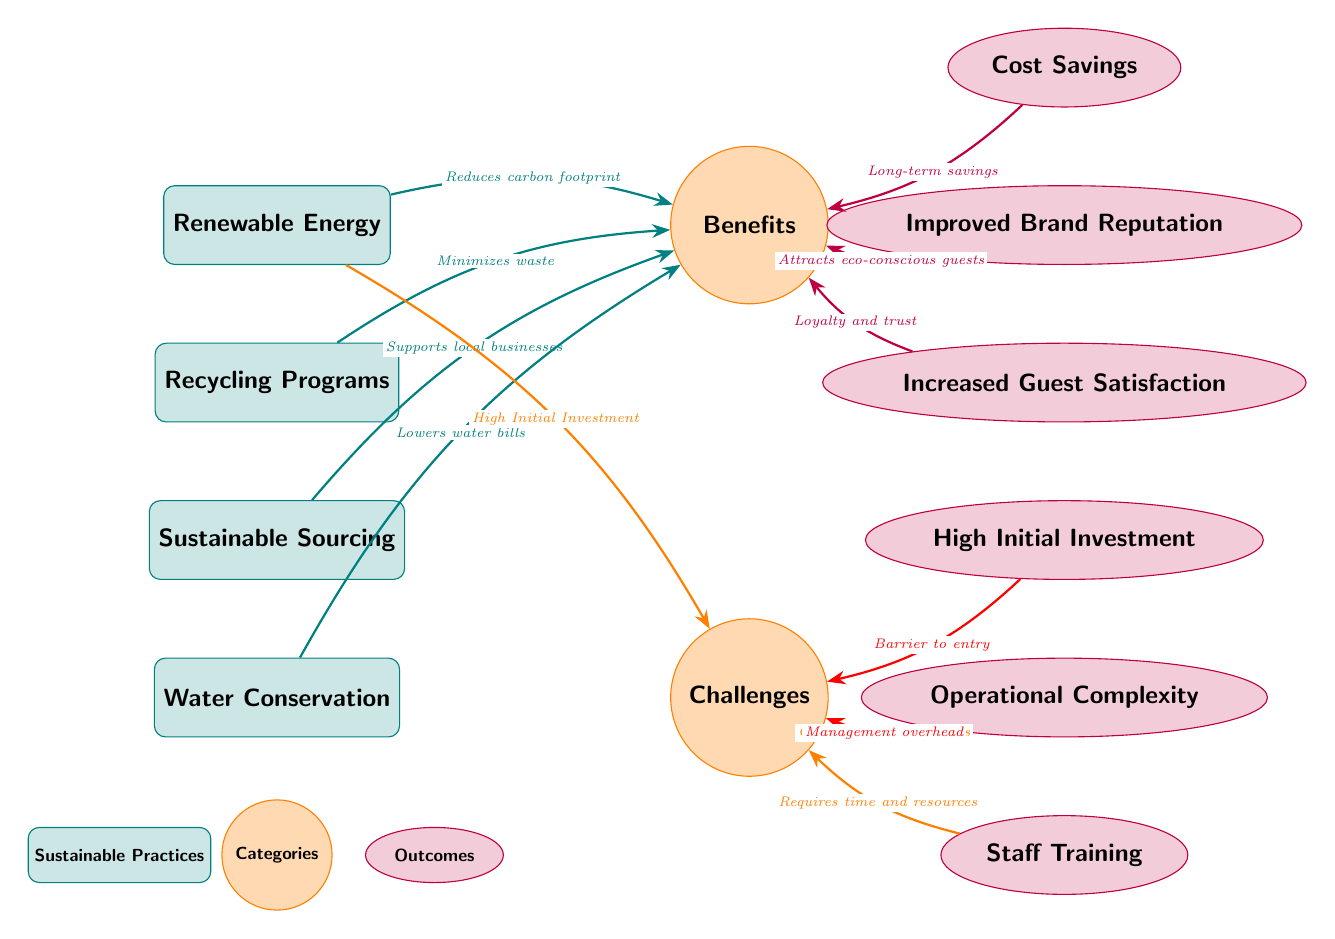What are the four sustainable practices listed in the diagram? The diagram clearly presents four practices: Renewable Energy, Recycling Programs, Sustainable Sourcing, and Water Conservation, each positioned in a straight vertical line.
Answer: Renewable Energy, Recycling Programs, Sustainable Sourcing, Water Conservation Which benefit is related to Renewable Energy? The arrow leading from Renewable Energy to the Benefits category indicates it reduces the carbon footprint, which is key to understanding its contribution.
Answer: Reduces carbon footprint How many challenges are listed in the diagram? By counting the nodes under the Challenges category, we can identify three distinct challenges: High Initial Investment, Operational Complexity, and Staff Training.
Answer: 3 What is the connection between Improved Brand Reputation and another node? The diagram shows an arrow pointing from Improved Brand Reputation to the Benefits category, indicating this outcome is a direct result of sustainable practices that enhance brand image.
Answer: Attracts eco-conscious guests Which sustainable practice supports local businesses? The Sustainable Sourcing practice has a direct connection to the Benefits category, where it states "Supports local businesses" as its outcome.
Answer: Sustainable Sourcing What is one challenge that relates to Staff Training? The diagram illustrates that Staff Training is tied to Operational Complexity, as indicated by the arrow that leads from Staff Training to the Challenges category, signifying it requires time and resources.
Answer: Requires time and resources How does Water Conservation directly benefit hotels? The diagram indicates that Water Conservation leads to lowered water bills, making this connection evident through the directed arrow towards the Benefits category.
Answer: Lowers water bills What is the outcome of implementing Renewable Energy? Following the arrows from Renewable Energy in the diagram, the primary outcome outlined is cost savings in the long-term perspective.
Answer: Cost Savings 